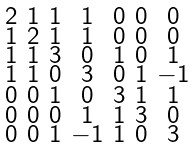<formula> <loc_0><loc_0><loc_500><loc_500>\begin{smallmatrix} 2 & 1 & 1 & 1 & 0 & 0 & 0 \\ 1 & 2 & 1 & 1 & 0 & 0 & 0 \\ 1 & 1 & 3 & 0 & 1 & 0 & 1 \\ 1 & 1 & 0 & 3 & 0 & 1 & - 1 \\ 0 & 0 & 1 & 0 & 3 & 1 & 1 \\ 0 & 0 & 0 & 1 & 1 & 3 & 0 \\ 0 & 0 & 1 & - 1 & 1 & 0 & 3 \end{smallmatrix}</formula> 